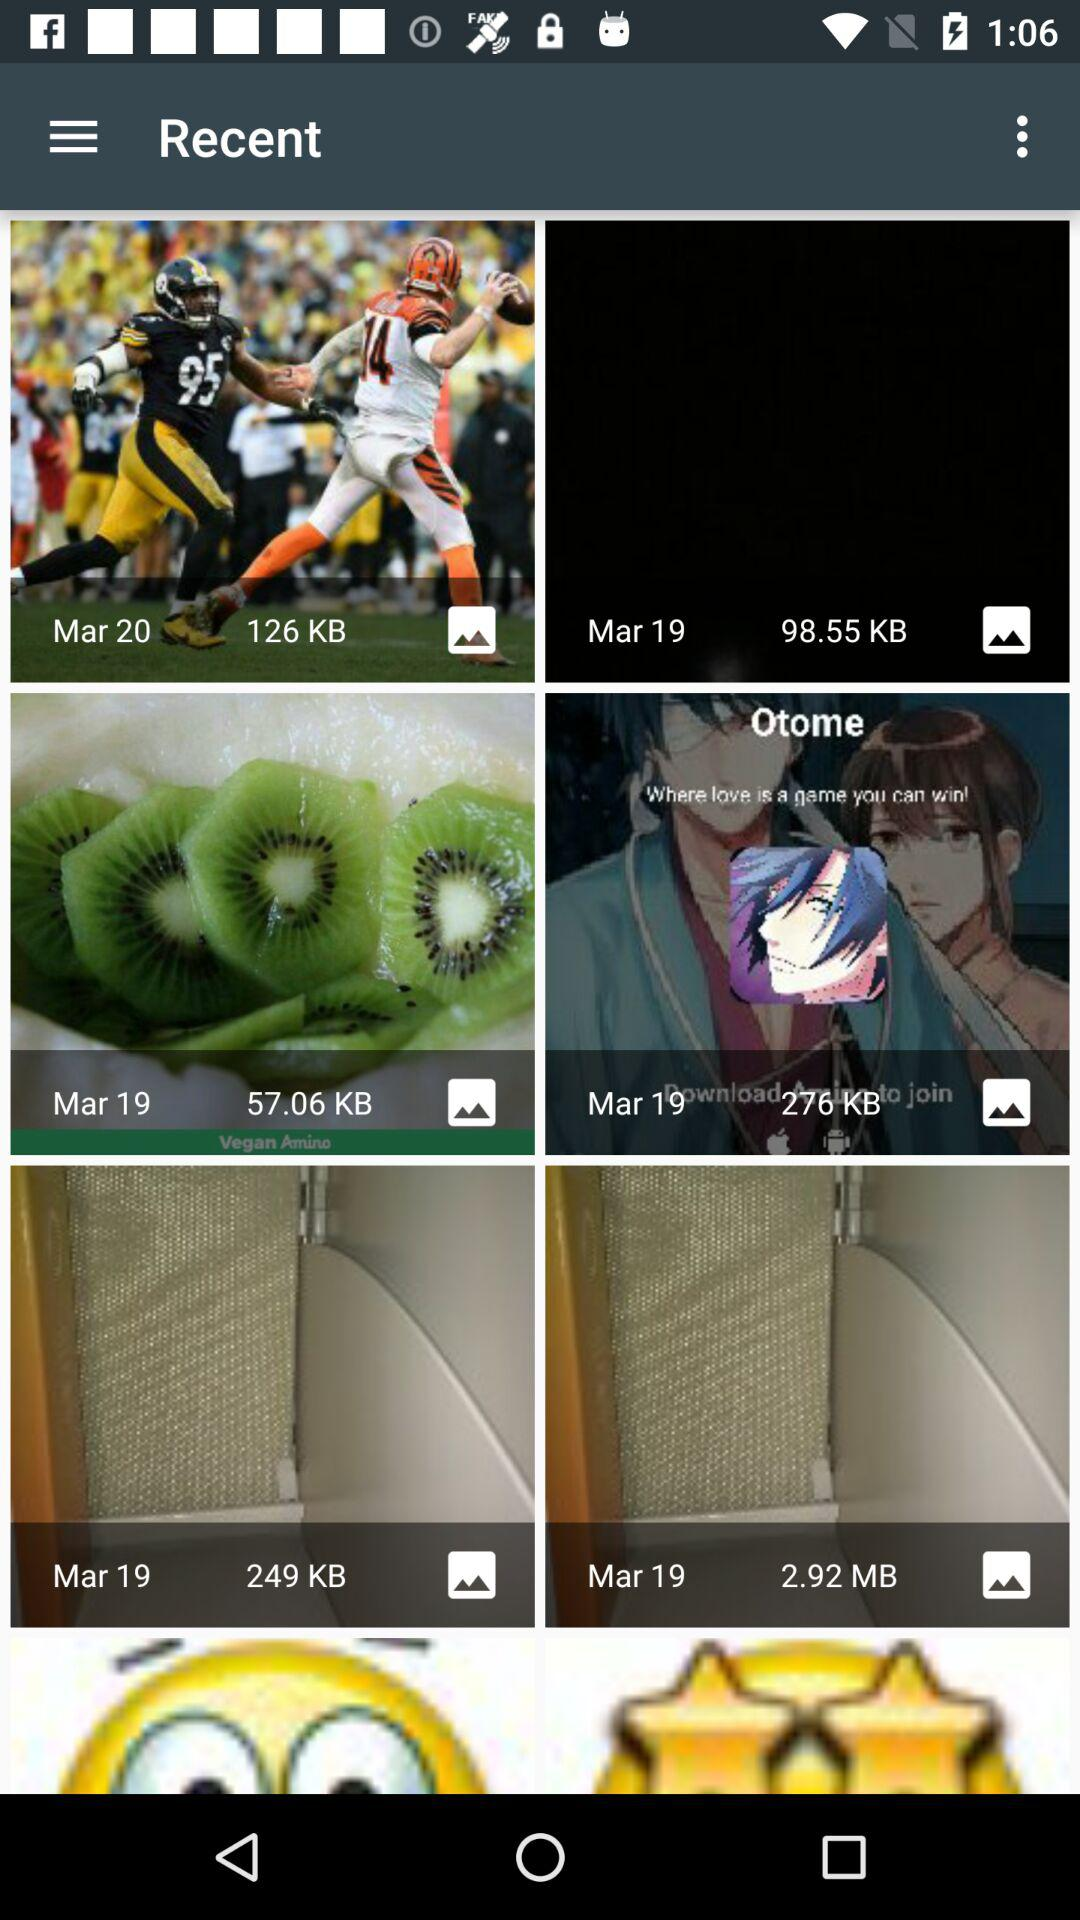On which date was a photo saved whose size is 276 KB? The date is March 19. 